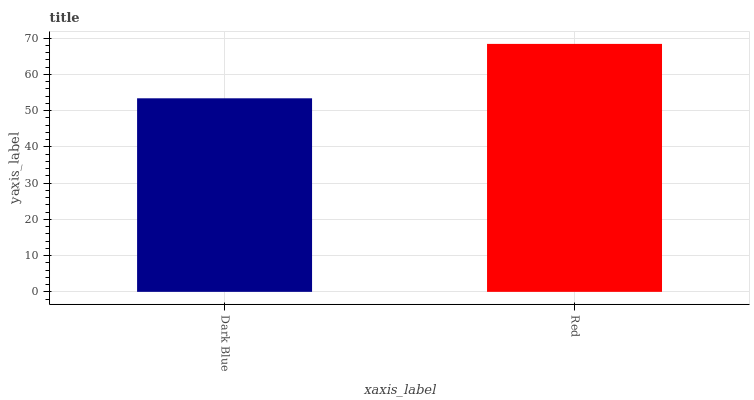Is Dark Blue the minimum?
Answer yes or no. Yes. Is Red the maximum?
Answer yes or no. Yes. Is Red the minimum?
Answer yes or no. No. Is Red greater than Dark Blue?
Answer yes or no. Yes. Is Dark Blue less than Red?
Answer yes or no. Yes. Is Dark Blue greater than Red?
Answer yes or no. No. Is Red less than Dark Blue?
Answer yes or no. No. Is Red the high median?
Answer yes or no. Yes. Is Dark Blue the low median?
Answer yes or no. Yes. Is Dark Blue the high median?
Answer yes or no. No. Is Red the low median?
Answer yes or no. No. 